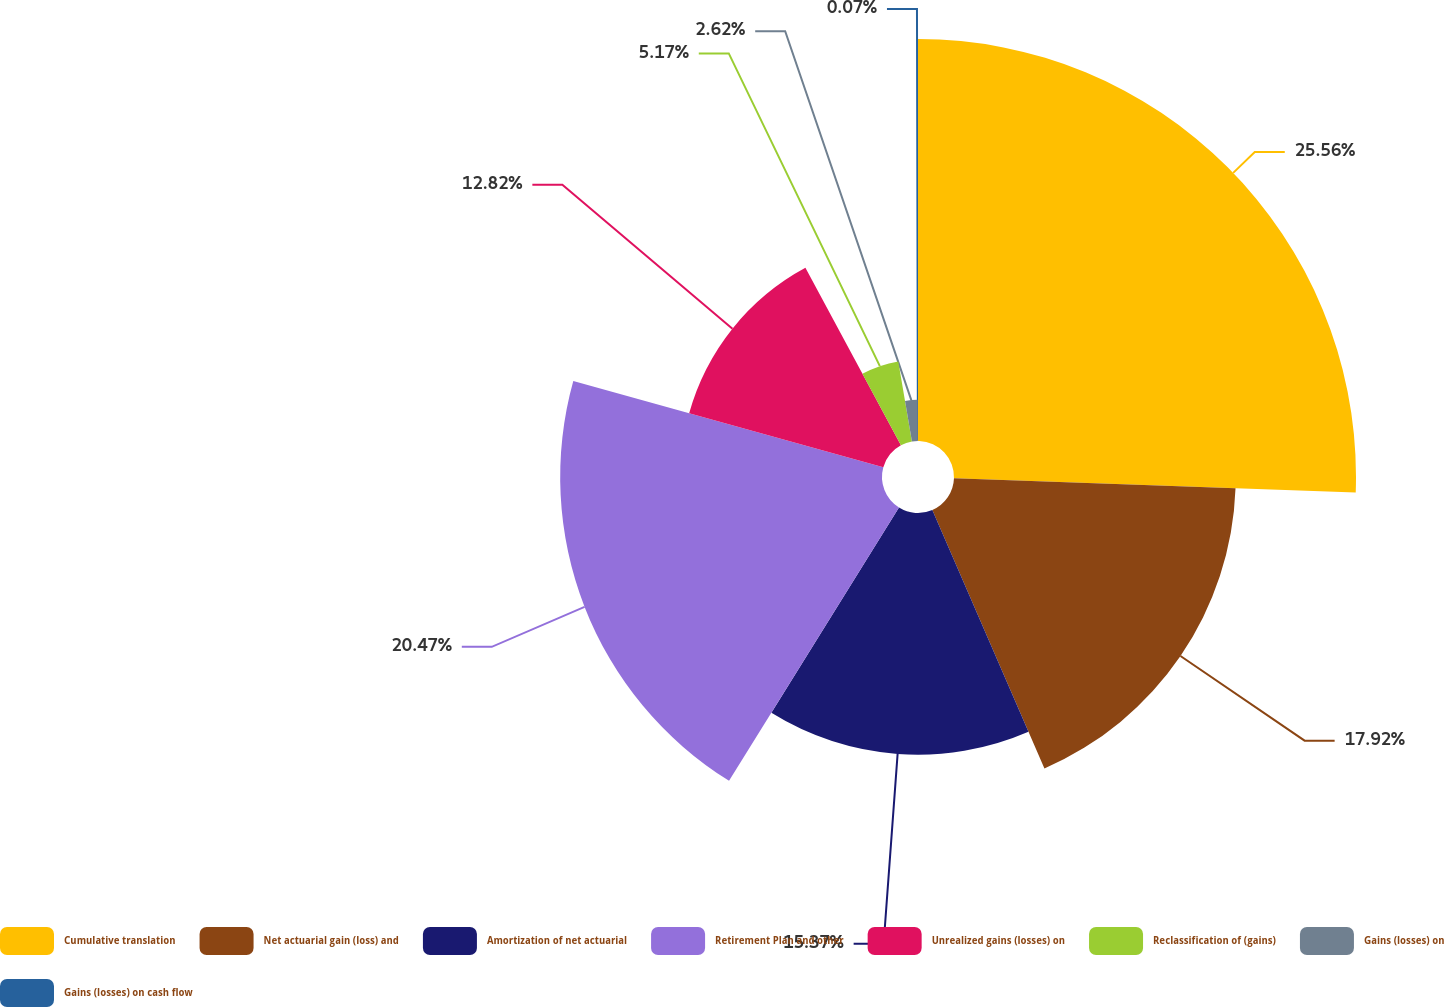<chart> <loc_0><loc_0><loc_500><loc_500><pie_chart><fcel>Cumulative translation<fcel>Net actuarial gain (loss) and<fcel>Amortization of net actuarial<fcel>Retirement Plan and other<fcel>Unrealized gains (losses) on<fcel>Reclassification of (gains)<fcel>Gains (losses) on<fcel>Gains (losses) on cash flow<nl><fcel>25.57%<fcel>17.92%<fcel>15.37%<fcel>20.47%<fcel>12.82%<fcel>5.17%<fcel>2.62%<fcel>0.07%<nl></chart> 